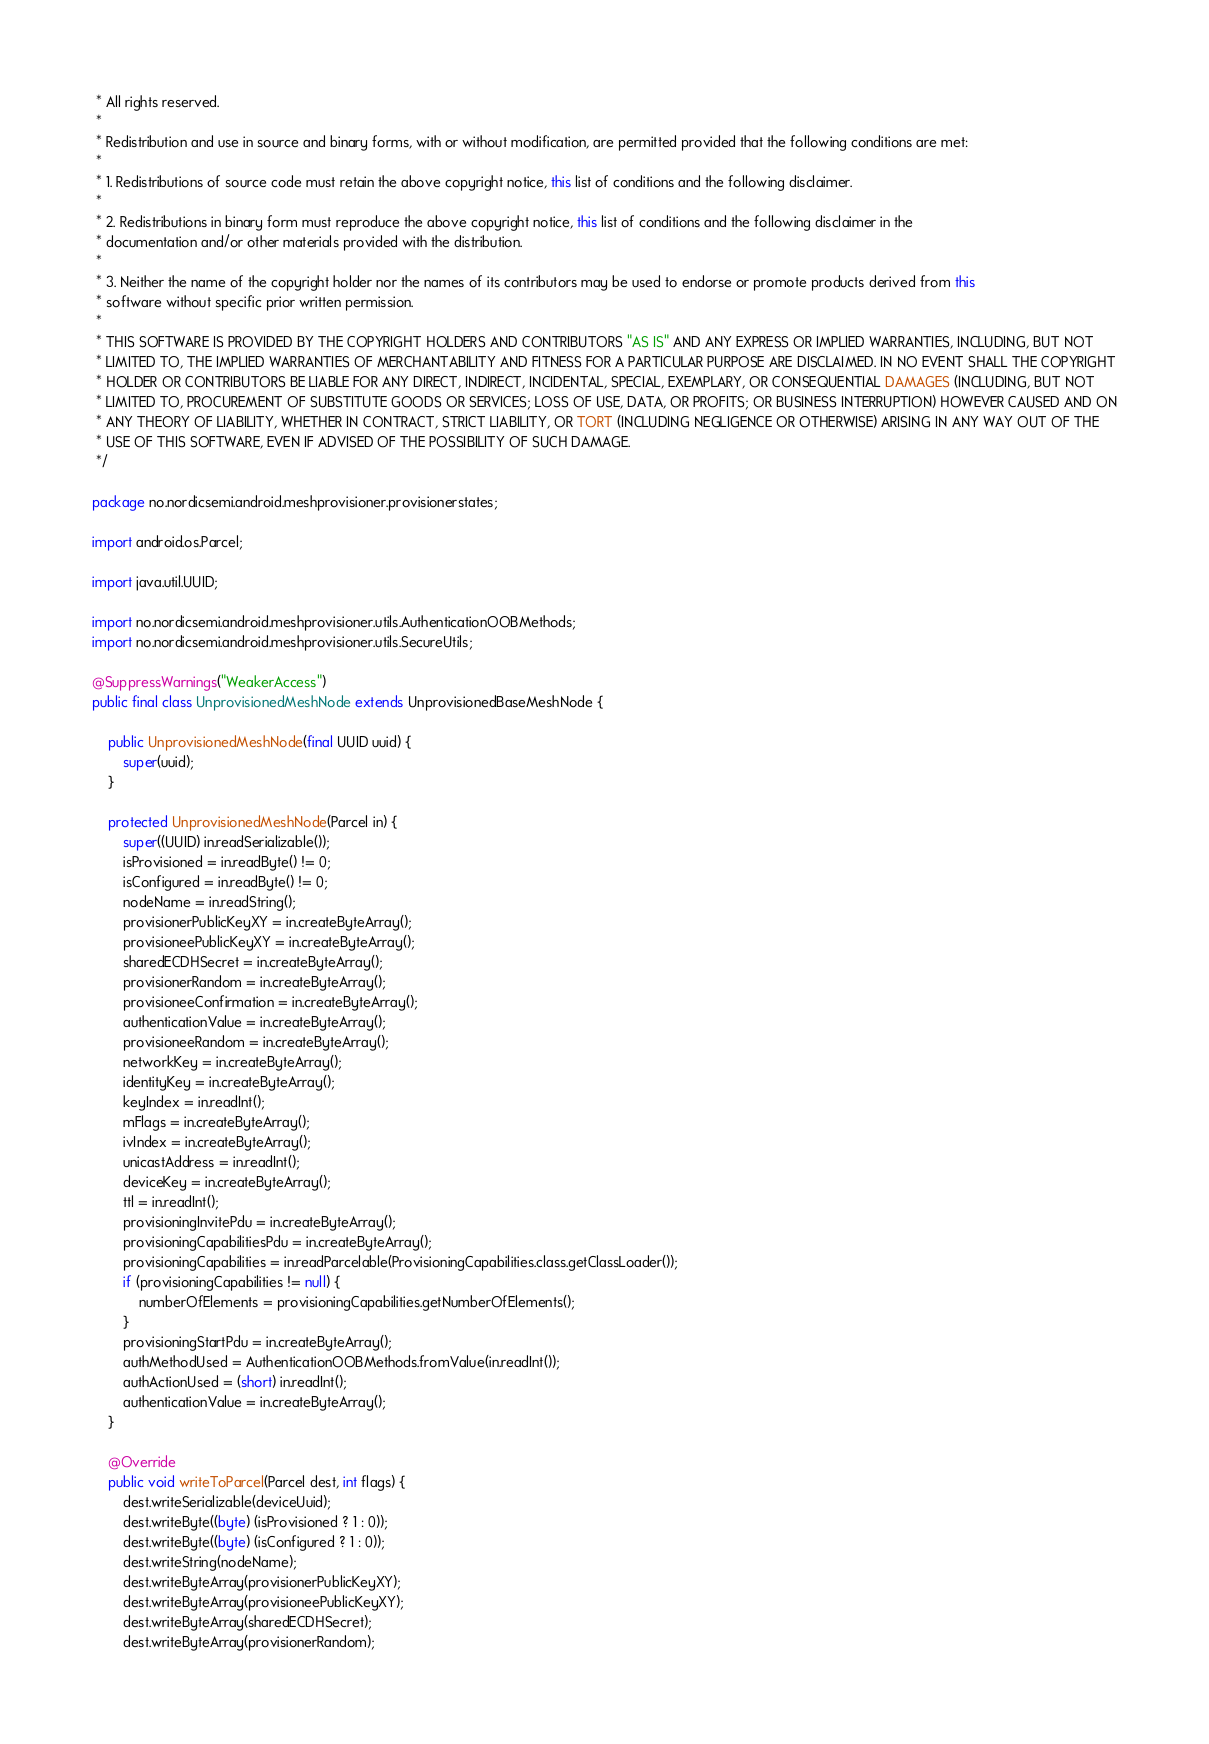<code> <loc_0><loc_0><loc_500><loc_500><_Java_> * All rights reserved.
 *
 * Redistribution and use in source and binary forms, with or without modification, are permitted provided that the following conditions are met:
 *
 * 1. Redistributions of source code must retain the above copyright notice, this list of conditions and the following disclaimer.
 *
 * 2. Redistributions in binary form must reproduce the above copyright notice, this list of conditions and the following disclaimer in the
 * documentation and/or other materials provided with the distribution.
 *
 * 3. Neither the name of the copyright holder nor the names of its contributors may be used to endorse or promote products derived from this
 * software without specific prior written permission.
 *
 * THIS SOFTWARE IS PROVIDED BY THE COPYRIGHT HOLDERS AND CONTRIBUTORS "AS IS" AND ANY EXPRESS OR IMPLIED WARRANTIES, INCLUDING, BUT NOT
 * LIMITED TO, THE IMPLIED WARRANTIES OF MERCHANTABILITY AND FITNESS FOR A PARTICULAR PURPOSE ARE DISCLAIMED. IN NO EVENT SHALL THE COPYRIGHT
 * HOLDER OR CONTRIBUTORS BE LIABLE FOR ANY DIRECT, INDIRECT, INCIDENTAL, SPECIAL, EXEMPLARY, OR CONSEQUENTIAL DAMAGES (INCLUDING, BUT NOT
 * LIMITED TO, PROCUREMENT OF SUBSTITUTE GOODS OR SERVICES; LOSS OF USE, DATA, OR PROFITS; OR BUSINESS INTERRUPTION) HOWEVER CAUSED AND ON
 * ANY THEORY OF LIABILITY, WHETHER IN CONTRACT, STRICT LIABILITY, OR TORT (INCLUDING NEGLIGENCE OR OTHERWISE) ARISING IN ANY WAY OUT OF THE
 * USE OF THIS SOFTWARE, EVEN IF ADVISED OF THE POSSIBILITY OF SUCH DAMAGE.
 */

package no.nordicsemi.android.meshprovisioner.provisionerstates;

import android.os.Parcel;

import java.util.UUID;

import no.nordicsemi.android.meshprovisioner.utils.AuthenticationOOBMethods;
import no.nordicsemi.android.meshprovisioner.utils.SecureUtils;

@SuppressWarnings("WeakerAccess")
public final class UnprovisionedMeshNode extends UnprovisionedBaseMeshNode {

    public UnprovisionedMeshNode(final UUID uuid) {
        super(uuid);
    }

    protected UnprovisionedMeshNode(Parcel in) {
        super((UUID) in.readSerializable());
        isProvisioned = in.readByte() != 0;
        isConfigured = in.readByte() != 0;
        nodeName = in.readString();
        provisionerPublicKeyXY = in.createByteArray();
        provisioneePublicKeyXY = in.createByteArray();
        sharedECDHSecret = in.createByteArray();
        provisionerRandom = in.createByteArray();
        provisioneeConfirmation = in.createByteArray();
        authenticationValue = in.createByteArray();
        provisioneeRandom = in.createByteArray();
        networkKey = in.createByteArray();
        identityKey = in.createByteArray();
        keyIndex = in.readInt();
        mFlags = in.createByteArray();
        ivIndex = in.createByteArray();
        unicastAddress = in.readInt();
        deviceKey = in.createByteArray();
        ttl = in.readInt();
        provisioningInvitePdu = in.createByteArray();
        provisioningCapabilitiesPdu = in.createByteArray();
        provisioningCapabilities = in.readParcelable(ProvisioningCapabilities.class.getClassLoader());
        if (provisioningCapabilities != null) {
            numberOfElements = provisioningCapabilities.getNumberOfElements();
        }
        provisioningStartPdu = in.createByteArray();
        authMethodUsed = AuthenticationOOBMethods.fromValue(in.readInt());
        authActionUsed = (short) in.readInt();
        authenticationValue = in.createByteArray();
    }

    @Override
    public void writeToParcel(Parcel dest, int flags) {
        dest.writeSerializable(deviceUuid);
        dest.writeByte((byte) (isProvisioned ? 1 : 0));
        dest.writeByte((byte) (isConfigured ? 1 : 0));
        dest.writeString(nodeName);
        dest.writeByteArray(provisionerPublicKeyXY);
        dest.writeByteArray(provisioneePublicKeyXY);
        dest.writeByteArray(sharedECDHSecret);
        dest.writeByteArray(provisionerRandom);</code> 